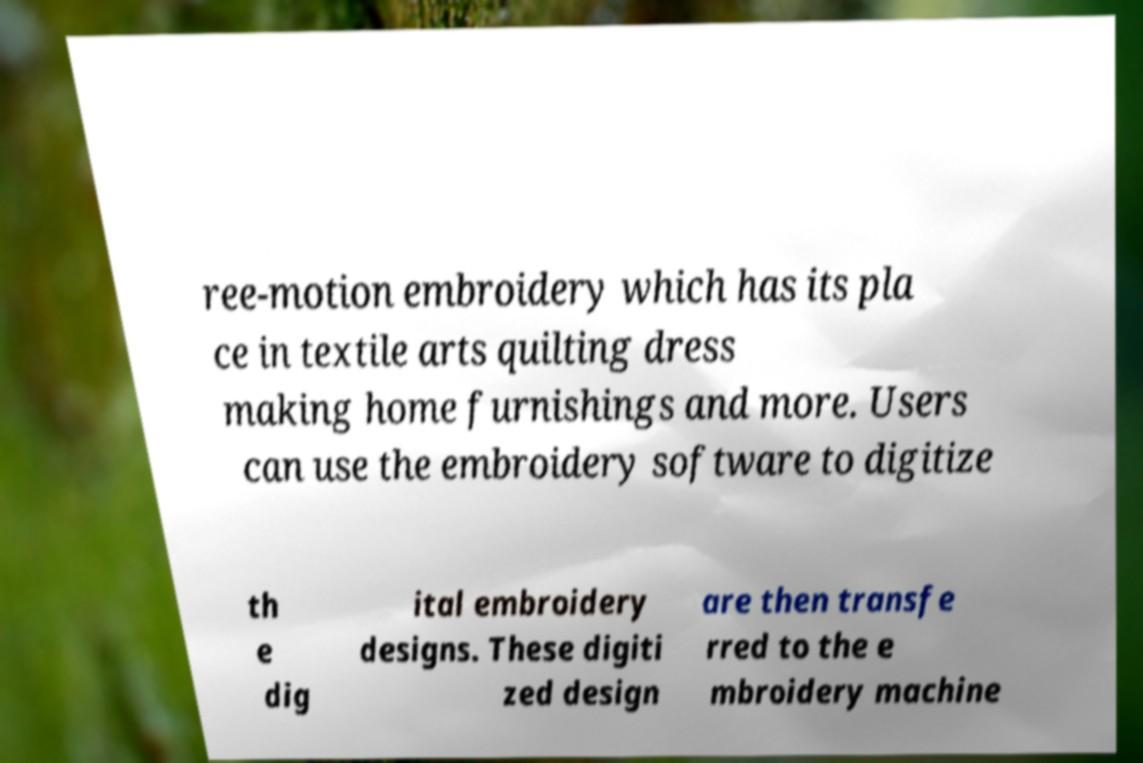Can you read and provide the text displayed in the image?This photo seems to have some interesting text. Can you extract and type it out for me? ree-motion embroidery which has its pla ce in textile arts quilting dress making home furnishings and more. Users can use the embroidery software to digitize th e dig ital embroidery designs. These digiti zed design are then transfe rred to the e mbroidery machine 